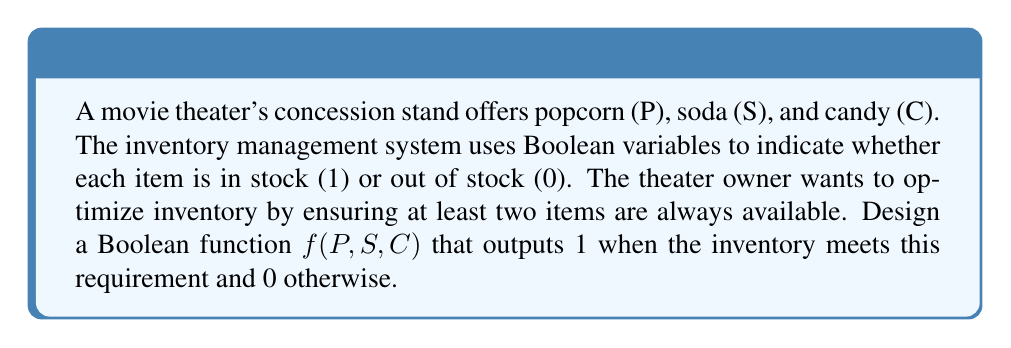Could you help me with this problem? To solve this problem, we'll follow these steps:

1) First, let's consider when the function should output 1:
   - When all three items are in stock: $P \cdot S \cdot C$
   - When any two items are in stock:
     $P \cdot S \cdot \overline{C} + P \cdot \overline{S} \cdot C + \overline{P} \cdot S \cdot C$

2) We can write the Boolean function as the sum of these terms:

   $f(P,S,C) = P \cdot S \cdot C + P \cdot S \cdot \overline{C} + P \cdot \overline{S} \cdot C + \overline{P} \cdot S \cdot C$

3) Let's simplify this expression:
   
   $f(P,S,C) = P \cdot S \cdot (C + \overline{C}) + P \cdot C \cdot (\overline{S}) + S \cdot C \cdot (\overline{P})$

4) Simplify further using the identity $X + \overline{X} = 1$:

   $f(P,S,C) = P \cdot S + P \cdot C \cdot \overline{S} + S \cdot C \cdot \overline{P}$

5) This is the simplified Boolean function that meets the inventory requirement.
Answer: $f(P,S,C) = P \cdot S + P \cdot C \cdot \overline{S} + S \cdot C \cdot \overline{P}$ 